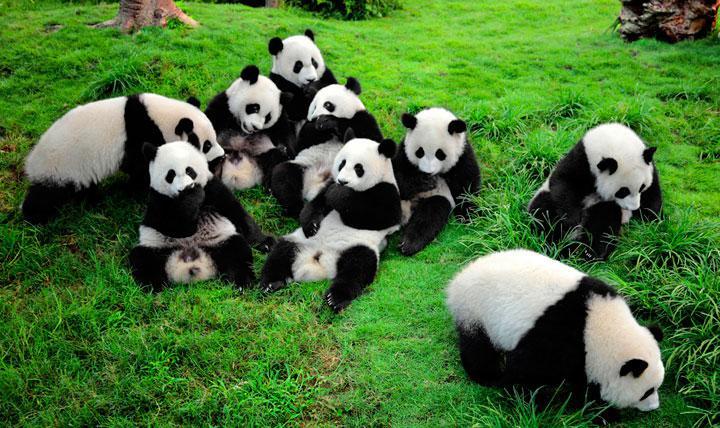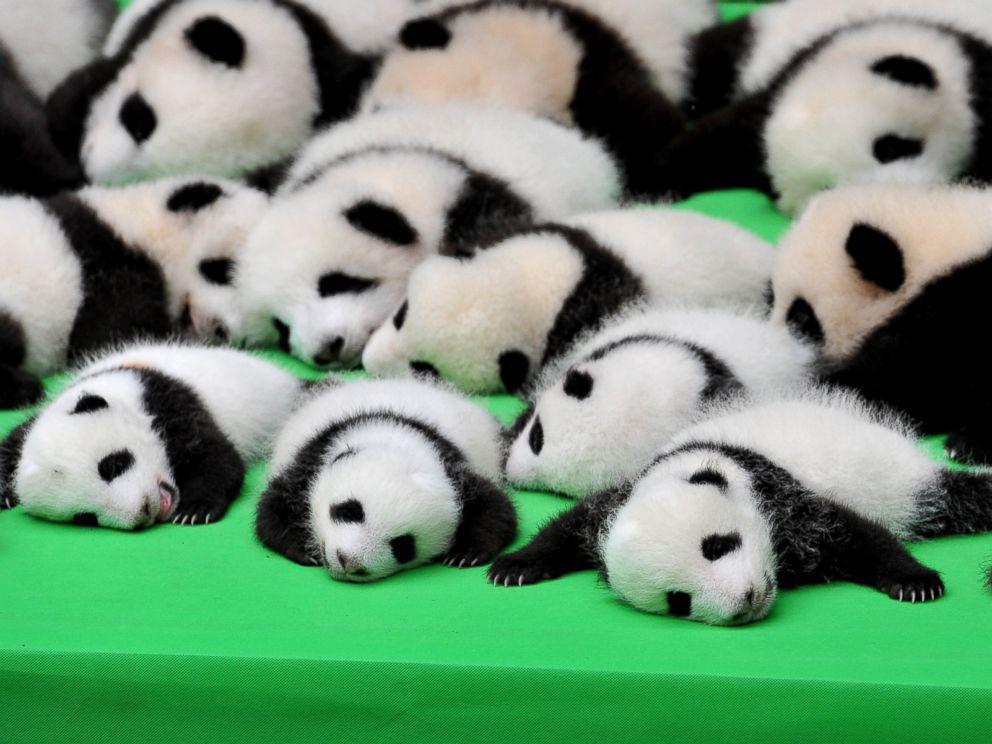The first image is the image on the left, the second image is the image on the right. Given the left and right images, does the statement "Both images show only baby pandas and no adult pandas." hold true? Answer yes or no. No. The first image is the image on the left, the second image is the image on the right. For the images shown, is this caption "At least one image shows multiple pandas piled on a flat green surface resembling a tablecloth." true? Answer yes or no. Yes. 